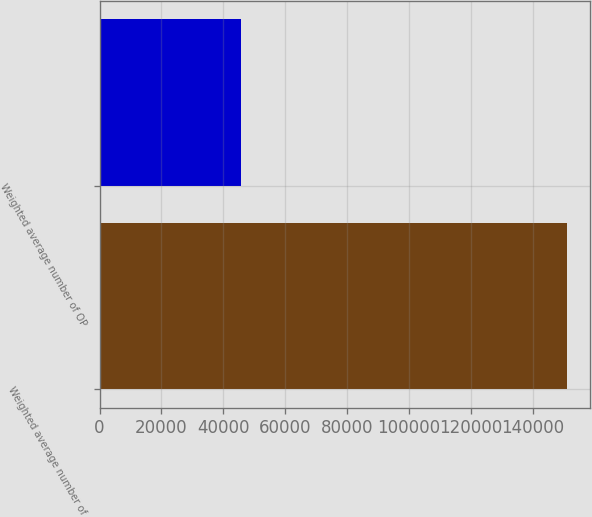Convert chart to OTSL. <chart><loc_0><loc_0><loc_500><loc_500><bar_chart><fcel>Weighted average number of<fcel>Weighted average number of OP<nl><fcel>151070<fcel>45651.3<nl></chart> 